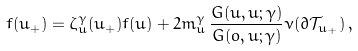Convert formula to latex. <formula><loc_0><loc_0><loc_500><loc_500>f ( u _ { + } ) & = \zeta _ { u } ^ { \gamma } ( u _ { + } ) f ( u ) + 2 m _ { u } ^ { \gamma } \, \frac { G ( u , u ; \gamma ) } { G ( o , u ; \gamma ) } \nu ( \partial \mathcal { T } _ { u _ { + } } ) \, ,</formula> 